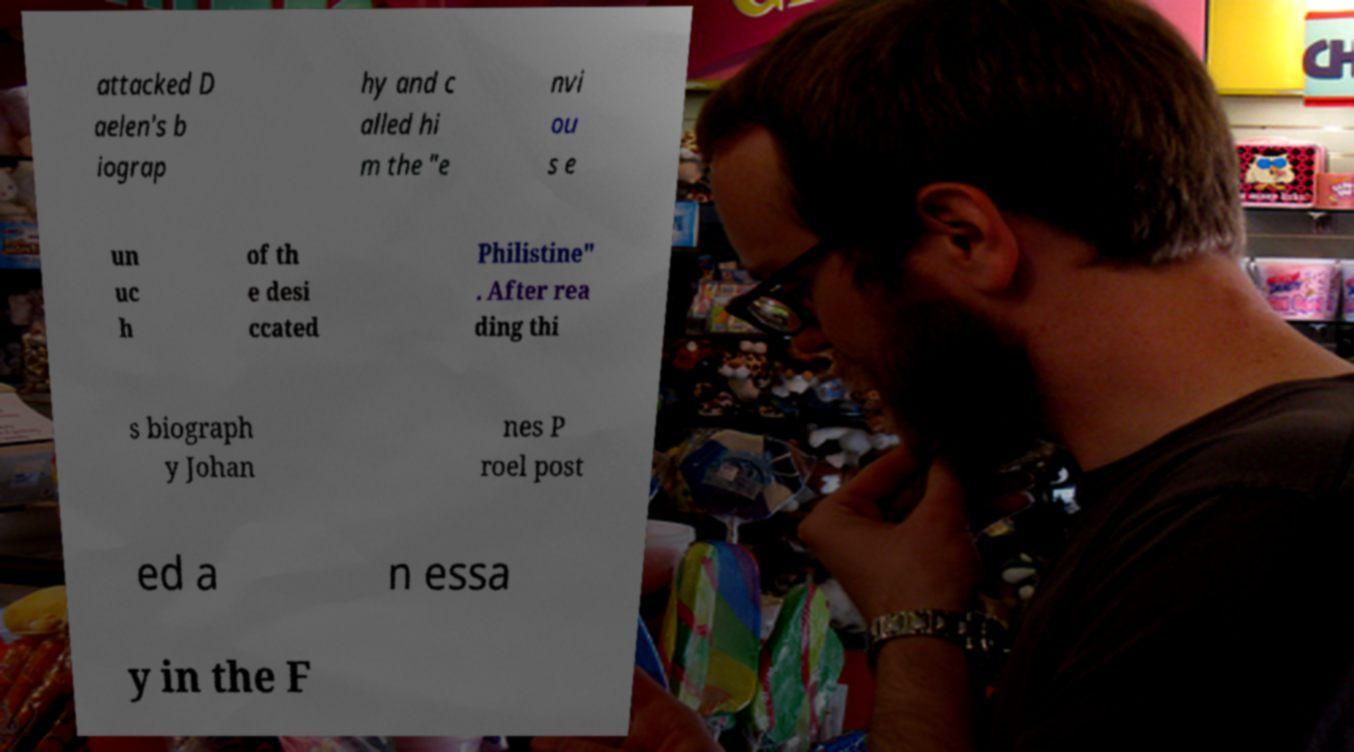What messages or text are displayed in this image? I need them in a readable, typed format. attacked D aelen's b iograp hy and c alled hi m the "e nvi ou s e un uc h of th e desi ccated Philistine" . After rea ding thi s biograph y Johan nes P roel post ed a n essa y in the F 